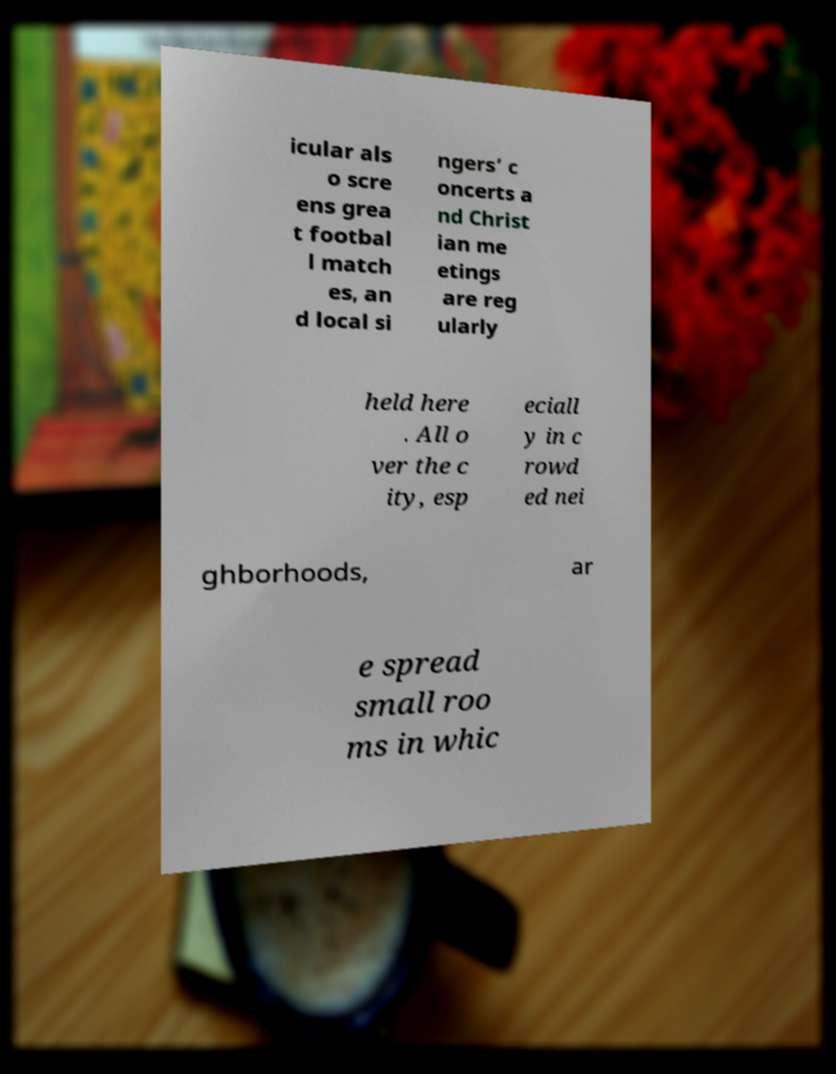For documentation purposes, I need the text within this image transcribed. Could you provide that? icular als o scre ens grea t footbal l match es, an d local si ngers’ c oncerts a nd Christ ian me etings are reg ularly held here . All o ver the c ity, esp eciall y in c rowd ed nei ghborhoods, ar e spread small roo ms in whic 